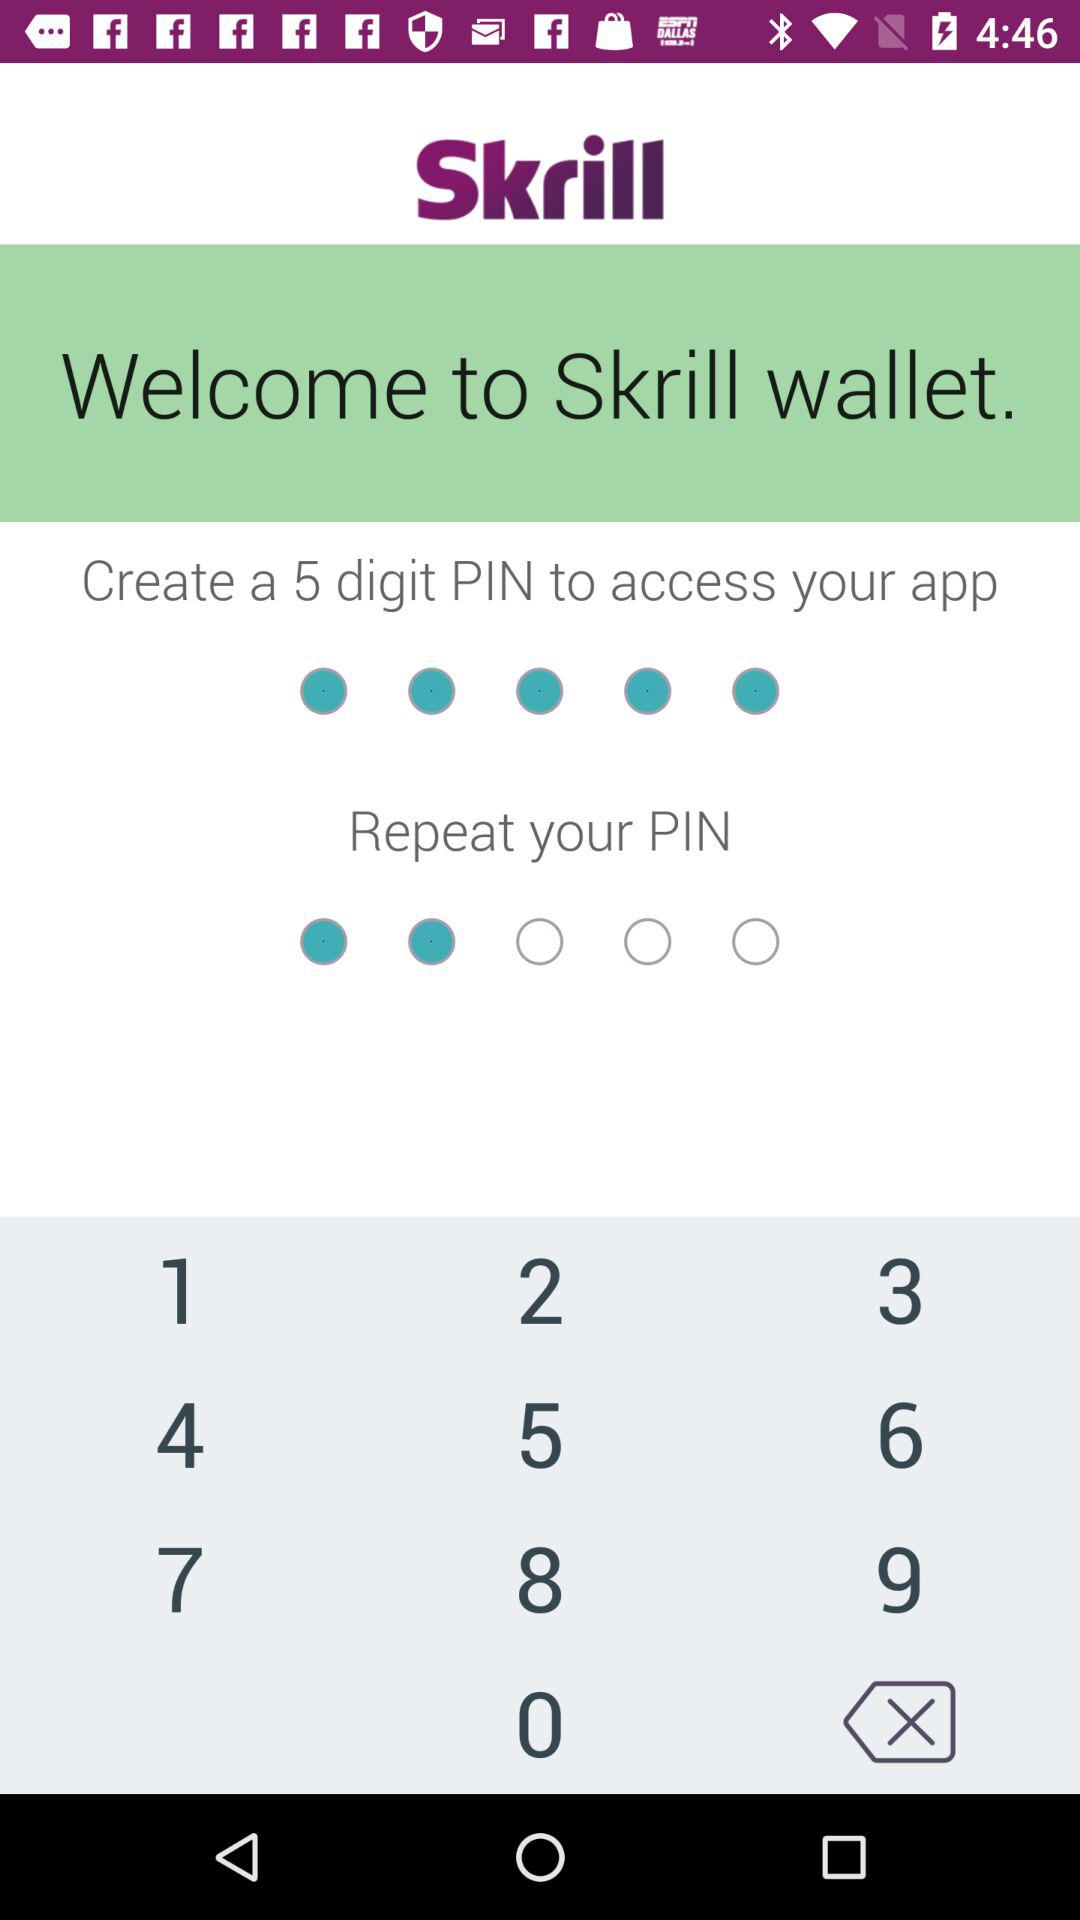What is the app name? The app name is "Skrill". 